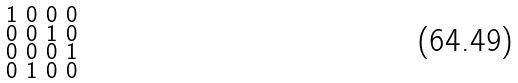<formula> <loc_0><loc_0><loc_500><loc_500>\begin{smallmatrix} 1 & 0 & 0 & 0 \\ 0 & 0 & 1 & 0 \\ 0 & 0 & 0 & 1 \\ 0 & 1 & 0 & 0 \end{smallmatrix}</formula> 